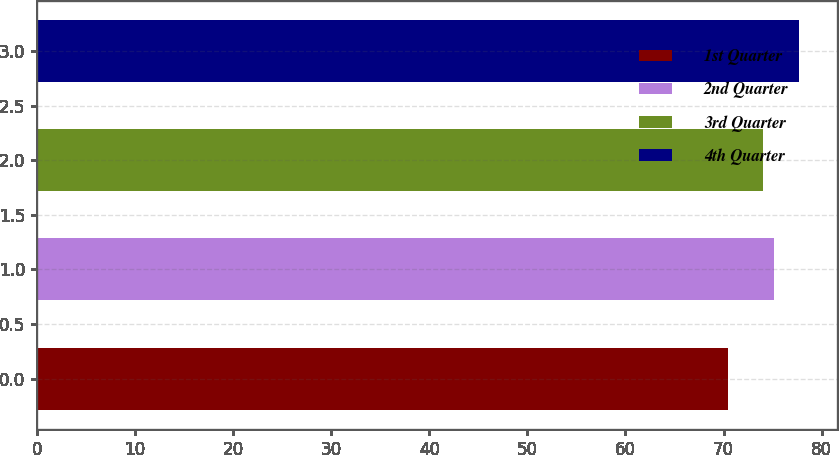Convert chart to OTSL. <chart><loc_0><loc_0><loc_500><loc_500><bar_chart><fcel>1st Quarter<fcel>2nd Quarter<fcel>3rd Quarter<fcel>4th Quarter<nl><fcel>70.45<fcel>75.17<fcel>74<fcel>77.67<nl></chart> 